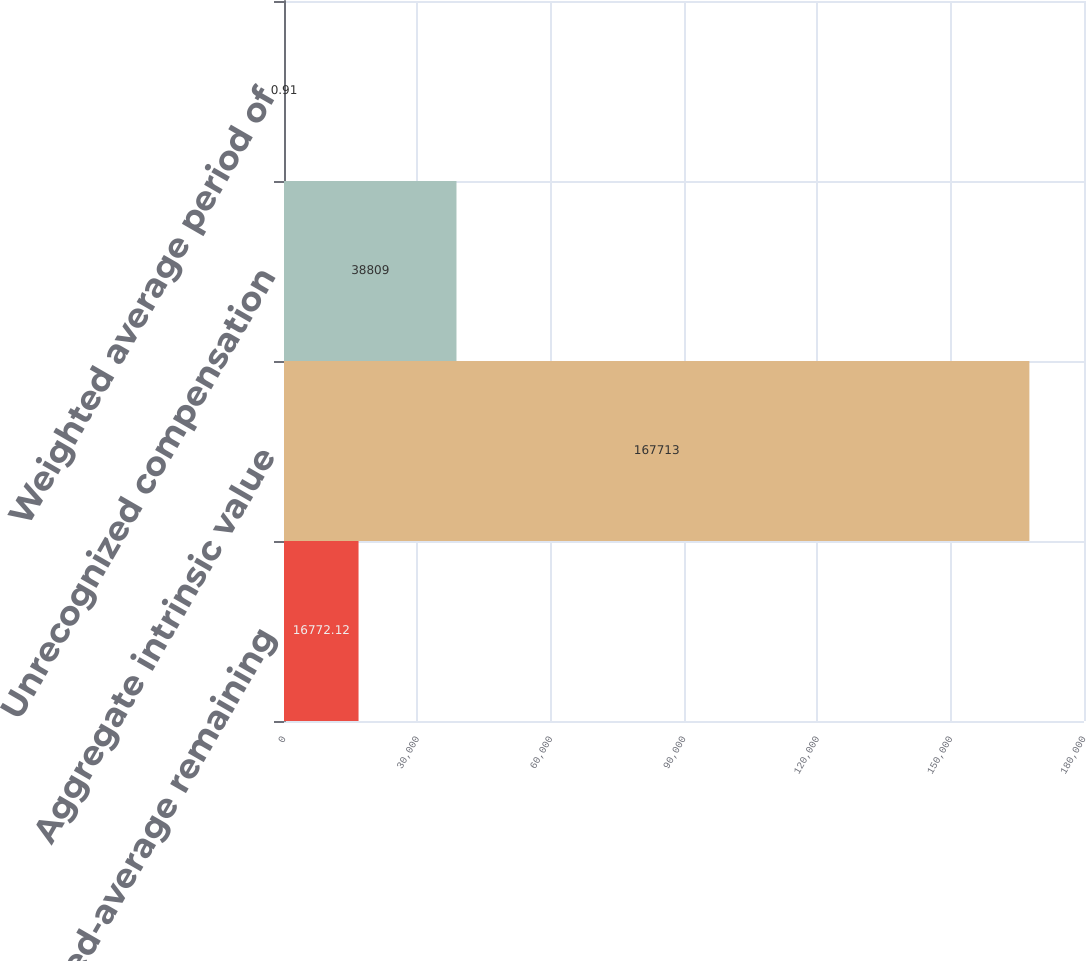Convert chart. <chart><loc_0><loc_0><loc_500><loc_500><bar_chart><fcel>Weighted-average remaining<fcel>Aggregate intrinsic value<fcel>Unrecognized compensation<fcel>Weighted average period of<nl><fcel>16772.1<fcel>167713<fcel>38809<fcel>0.91<nl></chart> 